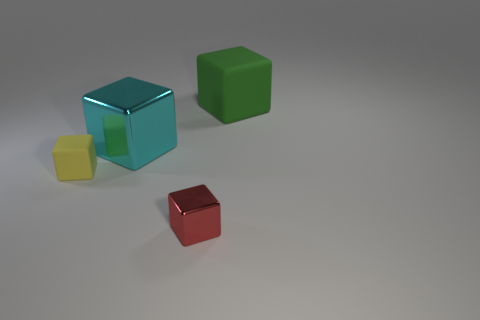Could you imagine a story where these objects play a significant role? Certainly! I can envision a story where these cubes are ancient artifacts, each holding a unique power based on their color. The cyan cube controls water, the green cube harnesses the earth, the red cube wields fire, and the small yellow cube can manipulate air. Together, they balance the elements of a mystical world, and a group of heroes must keep them safe from those who seek to use their powers for chaos. 